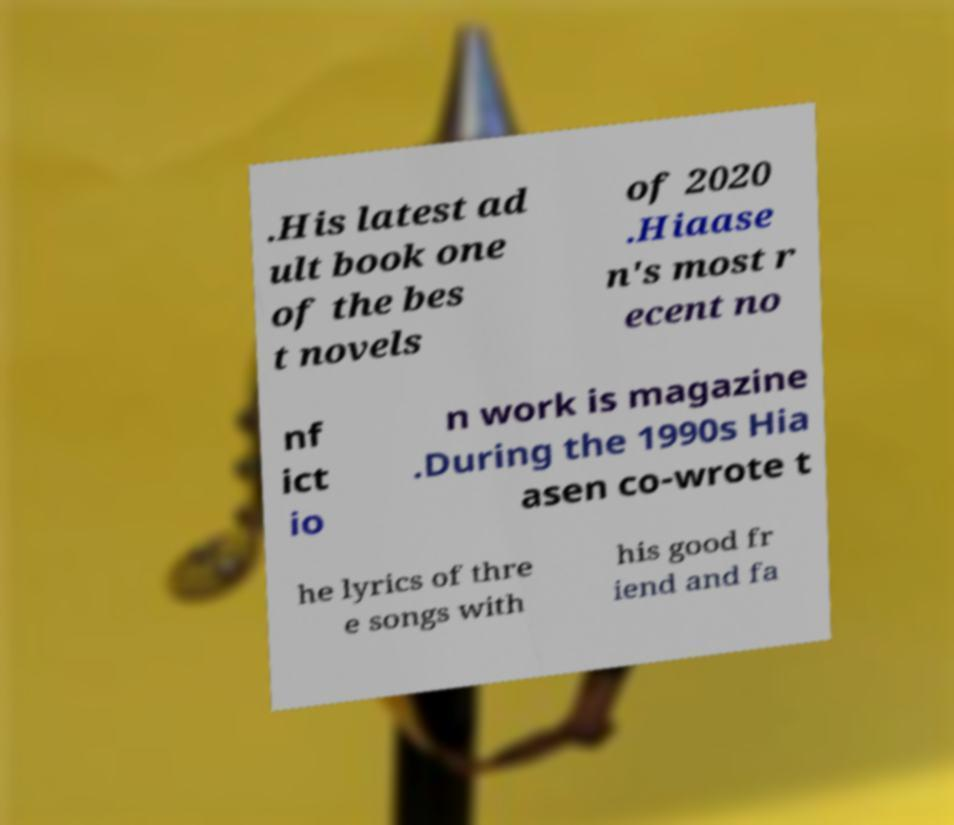There's text embedded in this image that I need extracted. Can you transcribe it verbatim? .His latest ad ult book one of the bes t novels of 2020 .Hiaase n's most r ecent no nf ict io n work is magazine .During the 1990s Hia asen co-wrote t he lyrics of thre e songs with his good fr iend and fa 